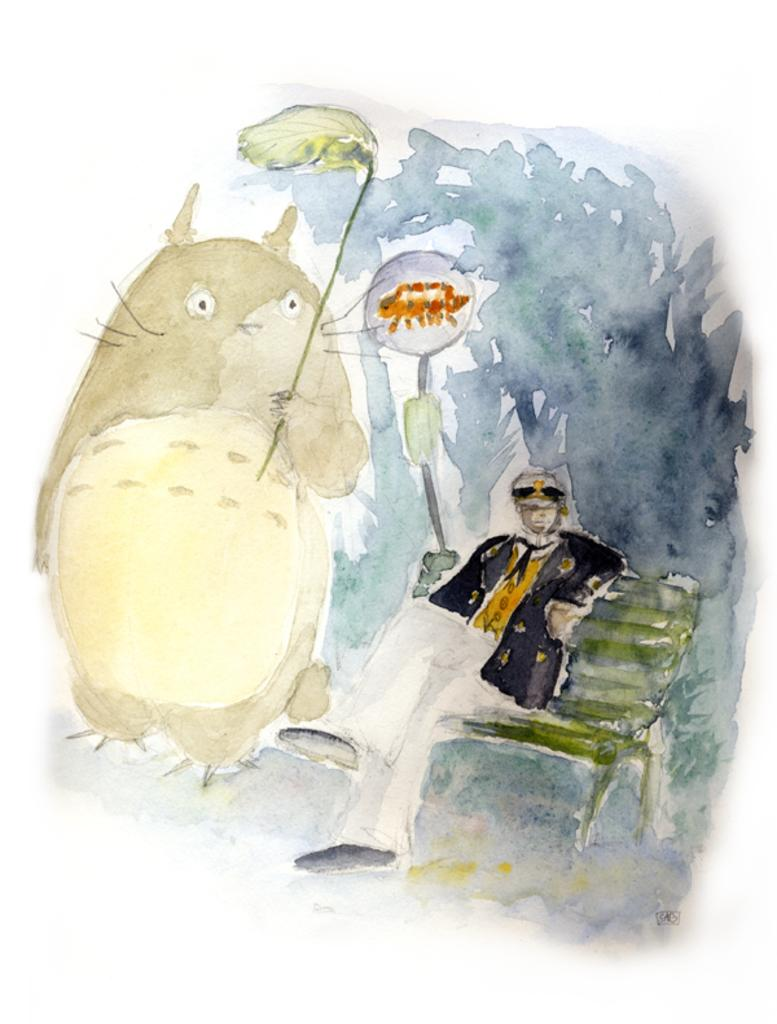What is the main subject of the image? There is a painting in the image. What is depicted in the painting? The painting contains an animal holding a leaf in its hand and a person sitting on a bench. What type of caption is written below the painting in the image? There is no caption written below the painting in the image. How does the animal's thumb look while holding the leaf in the painting? The painting does not show the animal's thumb, as it only depicts the animal holding a leaf in its hand. 